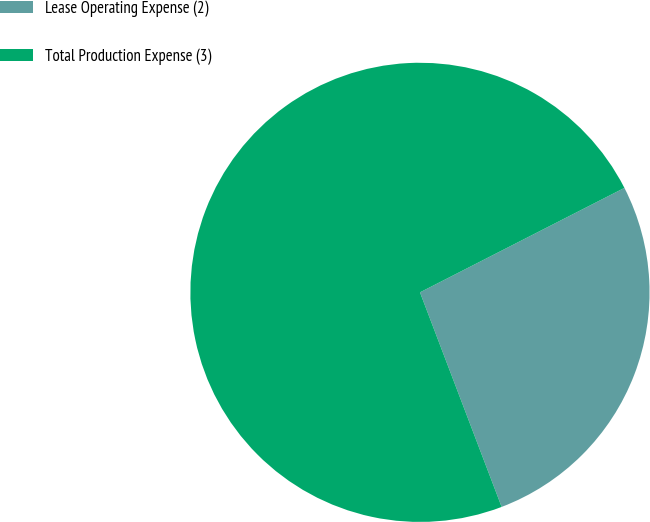<chart> <loc_0><loc_0><loc_500><loc_500><pie_chart><fcel>Lease Operating Expense (2)<fcel>Total Production Expense (3)<nl><fcel>26.73%<fcel>73.27%<nl></chart> 